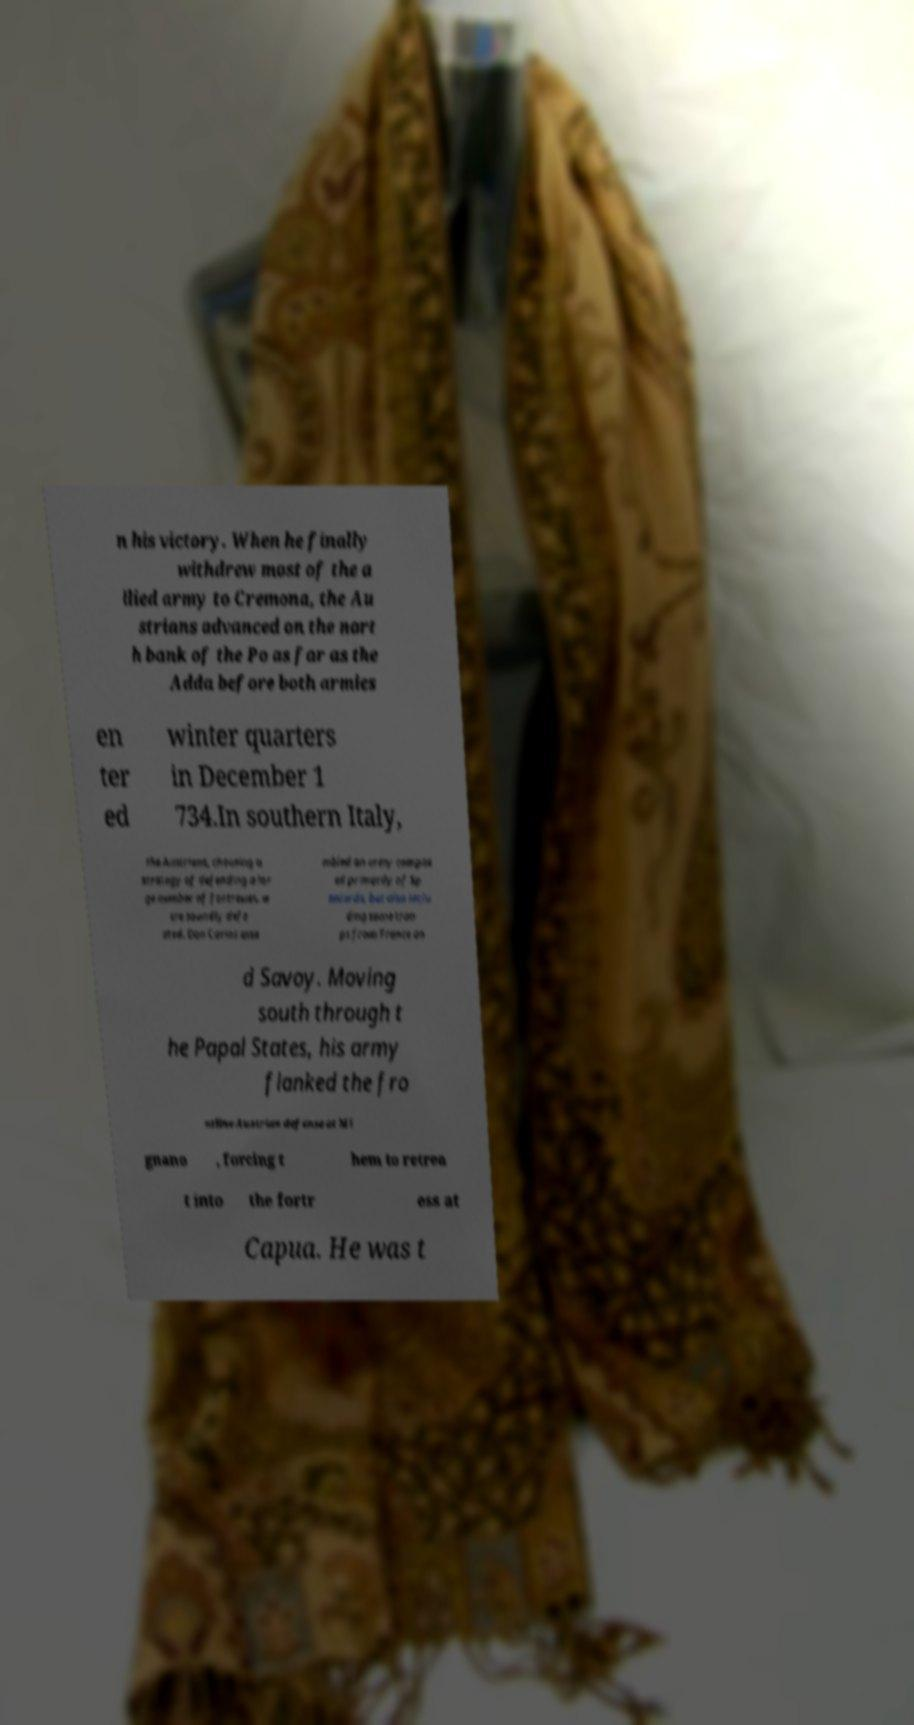For documentation purposes, I need the text within this image transcribed. Could you provide that? n his victory. When he finally withdrew most of the a llied army to Cremona, the Au strians advanced on the nort h bank of the Po as far as the Adda before both armies en ter ed winter quarters in December 1 734.In southern Italy, the Austrians, choosing a strategy of defending a lar ge number of fortresses, w ere soundly defe ated. Don Carlos asse mbled an army compos ed primarily of Sp aniards, but also inclu ding some troo ps from France an d Savoy. Moving south through t he Papal States, his army flanked the fro ntline Austrian defense at Mi gnano , forcing t hem to retrea t into the fortr ess at Capua. He was t 